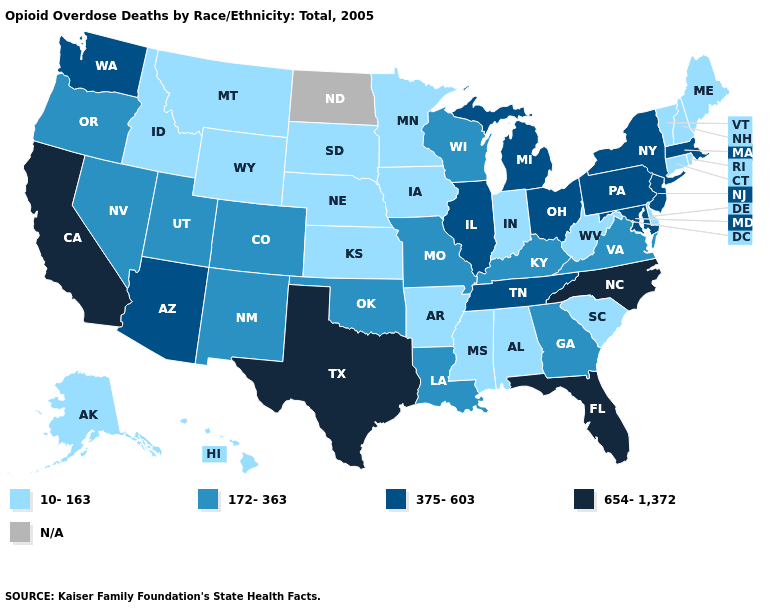How many symbols are there in the legend?
Give a very brief answer. 5. Which states have the highest value in the USA?
Quick response, please. California, Florida, North Carolina, Texas. Which states hav the highest value in the South?
Keep it brief. Florida, North Carolina, Texas. Which states have the lowest value in the USA?
Write a very short answer. Alabama, Alaska, Arkansas, Connecticut, Delaware, Hawaii, Idaho, Indiana, Iowa, Kansas, Maine, Minnesota, Mississippi, Montana, Nebraska, New Hampshire, Rhode Island, South Carolina, South Dakota, Vermont, West Virginia, Wyoming. Which states hav the highest value in the South?
Write a very short answer. Florida, North Carolina, Texas. Does the map have missing data?
Concise answer only. Yes. What is the lowest value in the South?
Quick response, please. 10-163. Name the states that have a value in the range 375-603?
Quick response, please. Arizona, Illinois, Maryland, Massachusetts, Michigan, New Jersey, New York, Ohio, Pennsylvania, Tennessee, Washington. Name the states that have a value in the range 375-603?
Answer briefly. Arizona, Illinois, Maryland, Massachusetts, Michigan, New Jersey, New York, Ohio, Pennsylvania, Tennessee, Washington. Does the first symbol in the legend represent the smallest category?
Concise answer only. Yes. What is the lowest value in states that border Kansas?
Quick response, please. 10-163. What is the highest value in the USA?
Be succinct. 654-1,372. Does the first symbol in the legend represent the smallest category?
Write a very short answer. Yes. What is the highest value in the USA?
Keep it brief. 654-1,372. 